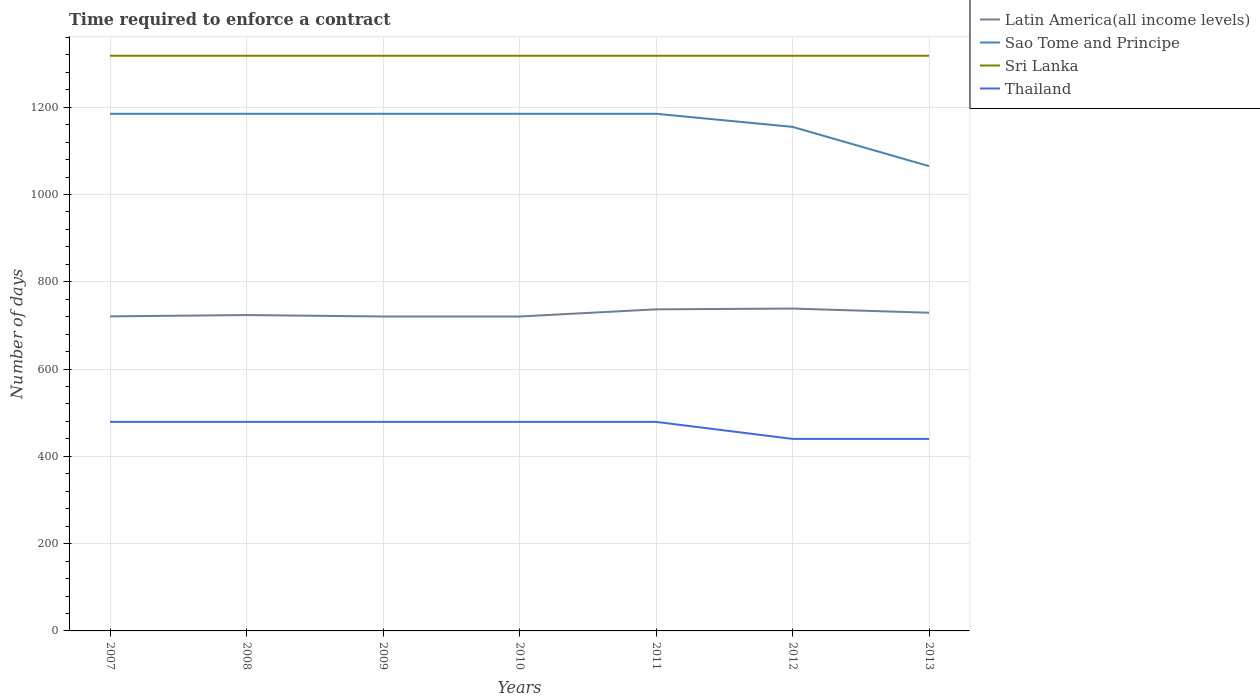How many different coloured lines are there?
Your answer should be compact. 4. Across all years, what is the maximum number of days required to enforce a contract in Sao Tome and Principe?
Offer a very short reply. 1065. In which year was the number of days required to enforce a contract in Latin America(all income levels) maximum?
Keep it short and to the point. 2009. What is the total number of days required to enforce a contract in Sri Lanka in the graph?
Provide a short and direct response. 0. What is the difference between the highest and the second highest number of days required to enforce a contract in Sao Tome and Principe?
Your response must be concise. 120. What is the difference between two consecutive major ticks on the Y-axis?
Keep it short and to the point. 200. Are the values on the major ticks of Y-axis written in scientific E-notation?
Provide a short and direct response. No. Does the graph contain grids?
Make the answer very short. Yes. How are the legend labels stacked?
Your response must be concise. Vertical. What is the title of the graph?
Offer a terse response. Time required to enforce a contract. Does "Thailand" appear as one of the legend labels in the graph?
Your answer should be compact. Yes. What is the label or title of the X-axis?
Your answer should be compact. Years. What is the label or title of the Y-axis?
Keep it short and to the point. Number of days. What is the Number of days in Latin America(all income levels) in 2007?
Keep it short and to the point. 720.8. What is the Number of days in Sao Tome and Principe in 2007?
Keep it short and to the point. 1185. What is the Number of days in Sri Lanka in 2007?
Make the answer very short. 1318. What is the Number of days of Thailand in 2007?
Your response must be concise. 479. What is the Number of days in Latin America(all income levels) in 2008?
Provide a short and direct response. 723.8. What is the Number of days in Sao Tome and Principe in 2008?
Make the answer very short. 1185. What is the Number of days in Sri Lanka in 2008?
Provide a short and direct response. 1318. What is the Number of days of Thailand in 2008?
Provide a short and direct response. 479. What is the Number of days of Latin America(all income levels) in 2009?
Your answer should be very brief. 720.47. What is the Number of days in Sao Tome and Principe in 2009?
Give a very brief answer. 1185. What is the Number of days in Sri Lanka in 2009?
Your answer should be very brief. 1318. What is the Number of days of Thailand in 2009?
Offer a terse response. 479. What is the Number of days of Latin America(all income levels) in 2010?
Provide a succinct answer. 720.47. What is the Number of days in Sao Tome and Principe in 2010?
Make the answer very short. 1185. What is the Number of days in Sri Lanka in 2010?
Make the answer very short. 1318. What is the Number of days in Thailand in 2010?
Your answer should be very brief. 479. What is the Number of days in Latin America(all income levels) in 2011?
Your answer should be very brief. 736.87. What is the Number of days of Sao Tome and Principe in 2011?
Your answer should be compact. 1185. What is the Number of days of Sri Lanka in 2011?
Your answer should be compact. 1318. What is the Number of days of Thailand in 2011?
Your answer should be compact. 479. What is the Number of days of Latin America(all income levels) in 2012?
Offer a terse response. 738.65. What is the Number of days in Sao Tome and Principe in 2012?
Your answer should be very brief. 1155. What is the Number of days of Sri Lanka in 2012?
Keep it short and to the point. 1318. What is the Number of days in Thailand in 2012?
Your answer should be compact. 440. What is the Number of days of Latin America(all income levels) in 2013?
Your response must be concise. 729.12. What is the Number of days of Sao Tome and Principe in 2013?
Offer a terse response. 1065. What is the Number of days of Sri Lanka in 2013?
Keep it short and to the point. 1318. What is the Number of days of Thailand in 2013?
Offer a very short reply. 440. Across all years, what is the maximum Number of days of Latin America(all income levels)?
Provide a succinct answer. 738.65. Across all years, what is the maximum Number of days of Sao Tome and Principe?
Your answer should be compact. 1185. Across all years, what is the maximum Number of days of Sri Lanka?
Offer a very short reply. 1318. Across all years, what is the maximum Number of days of Thailand?
Make the answer very short. 479. Across all years, what is the minimum Number of days in Latin America(all income levels)?
Offer a very short reply. 720.47. Across all years, what is the minimum Number of days in Sao Tome and Principe?
Give a very brief answer. 1065. Across all years, what is the minimum Number of days of Sri Lanka?
Keep it short and to the point. 1318. Across all years, what is the minimum Number of days of Thailand?
Offer a very short reply. 440. What is the total Number of days in Latin America(all income levels) in the graph?
Your answer should be compact. 5090.17. What is the total Number of days in Sao Tome and Principe in the graph?
Give a very brief answer. 8145. What is the total Number of days of Sri Lanka in the graph?
Ensure brevity in your answer.  9226. What is the total Number of days in Thailand in the graph?
Make the answer very short. 3275. What is the difference between the Number of days in Latin America(all income levels) in 2007 and that in 2008?
Offer a terse response. -3. What is the difference between the Number of days of Sao Tome and Principe in 2007 and that in 2008?
Make the answer very short. 0. What is the difference between the Number of days in Latin America(all income levels) in 2007 and that in 2009?
Offer a terse response. 0.33. What is the difference between the Number of days of Sri Lanka in 2007 and that in 2009?
Your answer should be very brief. 0. What is the difference between the Number of days in Latin America(all income levels) in 2007 and that in 2010?
Ensure brevity in your answer.  0.33. What is the difference between the Number of days of Sri Lanka in 2007 and that in 2010?
Offer a terse response. 0. What is the difference between the Number of days of Latin America(all income levels) in 2007 and that in 2011?
Provide a short and direct response. -16.07. What is the difference between the Number of days of Sri Lanka in 2007 and that in 2011?
Keep it short and to the point. 0. What is the difference between the Number of days in Thailand in 2007 and that in 2011?
Offer a terse response. 0. What is the difference between the Number of days in Latin America(all income levels) in 2007 and that in 2012?
Make the answer very short. -17.85. What is the difference between the Number of days of Sri Lanka in 2007 and that in 2012?
Give a very brief answer. 0. What is the difference between the Number of days in Thailand in 2007 and that in 2012?
Your response must be concise. 39. What is the difference between the Number of days of Latin America(all income levels) in 2007 and that in 2013?
Keep it short and to the point. -8.32. What is the difference between the Number of days in Sao Tome and Principe in 2007 and that in 2013?
Your answer should be very brief. 120. What is the difference between the Number of days of Latin America(all income levels) in 2008 and that in 2009?
Provide a short and direct response. 3.33. What is the difference between the Number of days of Sao Tome and Principe in 2008 and that in 2009?
Ensure brevity in your answer.  0. What is the difference between the Number of days of Sri Lanka in 2008 and that in 2009?
Keep it short and to the point. 0. What is the difference between the Number of days in Thailand in 2008 and that in 2009?
Offer a terse response. 0. What is the difference between the Number of days in Latin America(all income levels) in 2008 and that in 2010?
Make the answer very short. 3.33. What is the difference between the Number of days in Sao Tome and Principe in 2008 and that in 2010?
Ensure brevity in your answer.  0. What is the difference between the Number of days of Sri Lanka in 2008 and that in 2010?
Provide a succinct answer. 0. What is the difference between the Number of days of Thailand in 2008 and that in 2010?
Your answer should be compact. 0. What is the difference between the Number of days of Latin America(all income levels) in 2008 and that in 2011?
Provide a short and direct response. -13.07. What is the difference between the Number of days in Sri Lanka in 2008 and that in 2011?
Offer a terse response. 0. What is the difference between the Number of days of Thailand in 2008 and that in 2011?
Give a very brief answer. 0. What is the difference between the Number of days in Latin America(all income levels) in 2008 and that in 2012?
Make the answer very short. -14.85. What is the difference between the Number of days of Sao Tome and Principe in 2008 and that in 2012?
Your answer should be compact. 30. What is the difference between the Number of days of Sri Lanka in 2008 and that in 2012?
Offer a very short reply. 0. What is the difference between the Number of days in Latin America(all income levels) in 2008 and that in 2013?
Ensure brevity in your answer.  -5.32. What is the difference between the Number of days in Sao Tome and Principe in 2008 and that in 2013?
Your response must be concise. 120. What is the difference between the Number of days in Sri Lanka in 2008 and that in 2013?
Ensure brevity in your answer.  0. What is the difference between the Number of days of Latin America(all income levels) in 2009 and that in 2010?
Give a very brief answer. 0. What is the difference between the Number of days in Sri Lanka in 2009 and that in 2010?
Provide a short and direct response. 0. What is the difference between the Number of days of Thailand in 2009 and that in 2010?
Give a very brief answer. 0. What is the difference between the Number of days of Latin America(all income levels) in 2009 and that in 2011?
Offer a very short reply. -16.4. What is the difference between the Number of days in Latin America(all income levels) in 2009 and that in 2012?
Make the answer very short. -18.18. What is the difference between the Number of days of Thailand in 2009 and that in 2012?
Ensure brevity in your answer.  39. What is the difference between the Number of days in Latin America(all income levels) in 2009 and that in 2013?
Your response must be concise. -8.65. What is the difference between the Number of days in Sao Tome and Principe in 2009 and that in 2013?
Make the answer very short. 120. What is the difference between the Number of days in Latin America(all income levels) in 2010 and that in 2011?
Give a very brief answer. -16.4. What is the difference between the Number of days of Sao Tome and Principe in 2010 and that in 2011?
Provide a short and direct response. 0. What is the difference between the Number of days in Sri Lanka in 2010 and that in 2011?
Offer a very short reply. 0. What is the difference between the Number of days in Latin America(all income levels) in 2010 and that in 2012?
Give a very brief answer. -18.18. What is the difference between the Number of days of Sao Tome and Principe in 2010 and that in 2012?
Your response must be concise. 30. What is the difference between the Number of days of Thailand in 2010 and that in 2012?
Your response must be concise. 39. What is the difference between the Number of days in Latin America(all income levels) in 2010 and that in 2013?
Provide a short and direct response. -8.65. What is the difference between the Number of days of Sao Tome and Principe in 2010 and that in 2013?
Your response must be concise. 120. What is the difference between the Number of days of Latin America(all income levels) in 2011 and that in 2012?
Offer a very short reply. -1.77. What is the difference between the Number of days of Sri Lanka in 2011 and that in 2012?
Your answer should be compact. 0. What is the difference between the Number of days in Thailand in 2011 and that in 2012?
Offer a very short reply. 39. What is the difference between the Number of days in Latin America(all income levels) in 2011 and that in 2013?
Give a very brief answer. 7.75. What is the difference between the Number of days in Sao Tome and Principe in 2011 and that in 2013?
Keep it short and to the point. 120. What is the difference between the Number of days in Sri Lanka in 2011 and that in 2013?
Offer a terse response. 0. What is the difference between the Number of days of Latin America(all income levels) in 2012 and that in 2013?
Your answer should be very brief. 9.52. What is the difference between the Number of days of Thailand in 2012 and that in 2013?
Keep it short and to the point. 0. What is the difference between the Number of days of Latin America(all income levels) in 2007 and the Number of days of Sao Tome and Principe in 2008?
Make the answer very short. -464.2. What is the difference between the Number of days of Latin America(all income levels) in 2007 and the Number of days of Sri Lanka in 2008?
Keep it short and to the point. -597.2. What is the difference between the Number of days of Latin America(all income levels) in 2007 and the Number of days of Thailand in 2008?
Your answer should be compact. 241.8. What is the difference between the Number of days in Sao Tome and Principe in 2007 and the Number of days in Sri Lanka in 2008?
Your answer should be very brief. -133. What is the difference between the Number of days in Sao Tome and Principe in 2007 and the Number of days in Thailand in 2008?
Your response must be concise. 706. What is the difference between the Number of days in Sri Lanka in 2007 and the Number of days in Thailand in 2008?
Offer a very short reply. 839. What is the difference between the Number of days in Latin America(all income levels) in 2007 and the Number of days in Sao Tome and Principe in 2009?
Your response must be concise. -464.2. What is the difference between the Number of days of Latin America(all income levels) in 2007 and the Number of days of Sri Lanka in 2009?
Your answer should be compact. -597.2. What is the difference between the Number of days in Latin America(all income levels) in 2007 and the Number of days in Thailand in 2009?
Your response must be concise. 241.8. What is the difference between the Number of days of Sao Tome and Principe in 2007 and the Number of days of Sri Lanka in 2009?
Your answer should be compact. -133. What is the difference between the Number of days of Sao Tome and Principe in 2007 and the Number of days of Thailand in 2009?
Offer a very short reply. 706. What is the difference between the Number of days in Sri Lanka in 2007 and the Number of days in Thailand in 2009?
Provide a short and direct response. 839. What is the difference between the Number of days in Latin America(all income levels) in 2007 and the Number of days in Sao Tome and Principe in 2010?
Your answer should be very brief. -464.2. What is the difference between the Number of days in Latin America(all income levels) in 2007 and the Number of days in Sri Lanka in 2010?
Your answer should be very brief. -597.2. What is the difference between the Number of days in Latin America(all income levels) in 2007 and the Number of days in Thailand in 2010?
Offer a very short reply. 241.8. What is the difference between the Number of days of Sao Tome and Principe in 2007 and the Number of days of Sri Lanka in 2010?
Offer a terse response. -133. What is the difference between the Number of days of Sao Tome and Principe in 2007 and the Number of days of Thailand in 2010?
Provide a succinct answer. 706. What is the difference between the Number of days of Sri Lanka in 2007 and the Number of days of Thailand in 2010?
Offer a very short reply. 839. What is the difference between the Number of days in Latin America(all income levels) in 2007 and the Number of days in Sao Tome and Principe in 2011?
Make the answer very short. -464.2. What is the difference between the Number of days in Latin America(all income levels) in 2007 and the Number of days in Sri Lanka in 2011?
Ensure brevity in your answer.  -597.2. What is the difference between the Number of days of Latin America(all income levels) in 2007 and the Number of days of Thailand in 2011?
Your answer should be compact. 241.8. What is the difference between the Number of days of Sao Tome and Principe in 2007 and the Number of days of Sri Lanka in 2011?
Your answer should be very brief. -133. What is the difference between the Number of days of Sao Tome and Principe in 2007 and the Number of days of Thailand in 2011?
Offer a very short reply. 706. What is the difference between the Number of days of Sri Lanka in 2007 and the Number of days of Thailand in 2011?
Give a very brief answer. 839. What is the difference between the Number of days of Latin America(all income levels) in 2007 and the Number of days of Sao Tome and Principe in 2012?
Offer a terse response. -434.2. What is the difference between the Number of days of Latin America(all income levels) in 2007 and the Number of days of Sri Lanka in 2012?
Offer a very short reply. -597.2. What is the difference between the Number of days in Latin America(all income levels) in 2007 and the Number of days in Thailand in 2012?
Make the answer very short. 280.8. What is the difference between the Number of days in Sao Tome and Principe in 2007 and the Number of days in Sri Lanka in 2012?
Your response must be concise. -133. What is the difference between the Number of days in Sao Tome and Principe in 2007 and the Number of days in Thailand in 2012?
Make the answer very short. 745. What is the difference between the Number of days of Sri Lanka in 2007 and the Number of days of Thailand in 2012?
Provide a succinct answer. 878. What is the difference between the Number of days in Latin America(all income levels) in 2007 and the Number of days in Sao Tome and Principe in 2013?
Make the answer very short. -344.2. What is the difference between the Number of days of Latin America(all income levels) in 2007 and the Number of days of Sri Lanka in 2013?
Keep it short and to the point. -597.2. What is the difference between the Number of days of Latin America(all income levels) in 2007 and the Number of days of Thailand in 2013?
Keep it short and to the point. 280.8. What is the difference between the Number of days of Sao Tome and Principe in 2007 and the Number of days of Sri Lanka in 2013?
Make the answer very short. -133. What is the difference between the Number of days in Sao Tome and Principe in 2007 and the Number of days in Thailand in 2013?
Your answer should be compact. 745. What is the difference between the Number of days in Sri Lanka in 2007 and the Number of days in Thailand in 2013?
Give a very brief answer. 878. What is the difference between the Number of days in Latin America(all income levels) in 2008 and the Number of days in Sao Tome and Principe in 2009?
Provide a succinct answer. -461.2. What is the difference between the Number of days of Latin America(all income levels) in 2008 and the Number of days of Sri Lanka in 2009?
Your response must be concise. -594.2. What is the difference between the Number of days of Latin America(all income levels) in 2008 and the Number of days of Thailand in 2009?
Offer a very short reply. 244.8. What is the difference between the Number of days in Sao Tome and Principe in 2008 and the Number of days in Sri Lanka in 2009?
Provide a short and direct response. -133. What is the difference between the Number of days in Sao Tome and Principe in 2008 and the Number of days in Thailand in 2009?
Provide a short and direct response. 706. What is the difference between the Number of days in Sri Lanka in 2008 and the Number of days in Thailand in 2009?
Provide a short and direct response. 839. What is the difference between the Number of days in Latin America(all income levels) in 2008 and the Number of days in Sao Tome and Principe in 2010?
Offer a terse response. -461.2. What is the difference between the Number of days of Latin America(all income levels) in 2008 and the Number of days of Sri Lanka in 2010?
Your answer should be very brief. -594.2. What is the difference between the Number of days in Latin America(all income levels) in 2008 and the Number of days in Thailand in 2010?
Your response must be concise. 244.8. What is the difference between the Number of days of Sao Tome and Principe in 2008 and the Number of days of Sri Lanka in 2010?
Offer a terse response. -133. What is the difference between the Number of days in Sao Tome and Principe in 2008 and the Number of days in Thailand in 2010?
Give a very brief answer. 706. What is the difference between the Number of days in Sri Lanka in 2008 and the Number of days in Thailand in 2010?
Your answer should be compact. 839. What is the difference between the Number of days in Latin America(all income levels) in 2008 and the Number of days in Sao Tome and Principe in 2011?
Your response must be concise. -461.2. What is the difference between the Number of days of Latin America(all income levels) in 2008 and the Number of days of Sri Lanka in 2011?
Give a very brief answer. -594.2. What is the difference between the Number of days in Latin America(all income levels) in 2008 and the Number of days in Thailand in 2011?
Keep it short and to the point. 244.8. What is the difference between the Number of days of Sao Tome and Principe in 2008 and the Number of days of Sri Lanka in 2011?
Give a very brief answer. -133. What is the difference between the Number of days in Sao Tome and Principe in 2008 and the Number of days in Thailand in 2011?
Keep it short and to the point. 706. What is the difference between the Number of days of Sri Lanka in 2008 and the Number of days of Thailand in 2011?
Your response must be concise. 839. What is the difference between the Number of days of Latin America(all income levels) in 2008 and the Number of days of Sao Tome and Principe in 2012?
Give a very brief answer. -431.2. What is the difference between the Number of days in Latin America(all income levels) in 2008 and the Number of days in Sri Lanka in 2012?
Your response must be concise. -594.2. What is the difference between the Number of days of Latin America(all income levels) in 2008 and the Number of days of Thailand in 2012?
Provide a short and direct response. 283.8. What is the difference between the Number of days of Sao Tome and Principe in 2008 and the Number of days of Sri Lanka in 2012?
Offer a very short reply. -133. What is the difference between the Number of days of Sao Tome and Principe in 2008 and the Number of days of Thailand in 2012?
Provide a succinct answer. 745. What is the difference between the Number of days in Sri Lanka in 2008 and the Number of days in Thailand in 2012?
Make the answer very short. 878. What is the difference between the Number of days in Latin America(all income levels) in 2008 and the Number of days in Sao Tome and Principe in 2013?
Your answer should be very brief. -341.2. What is the difference between the Number of days in Latin America(all income levels) in 2008 and the Number of days in Sri Lanka in 2013?
Ensure brevity in your answer.  -594.2. What is the difference between the Number of days in Latin America(all income levels) in 2008 and the Number of days in Thailand in 2013?
Offer a terse response. 283.8. What is the difference between the Number of days in Sao Tome and Principe in 2008 and the Number of days in Sri Lanka in 2013?
Give a very brief answer. -133. What is the difference between the Number of days of Sao Tome and Principe in 2008 and the Number of days of Thailand in 2013?
Give a very brief answer. 745. What is the difference between the Number of days of Sri Lanka in 2008 and the Number of days of Thailand in 2013?
Your response must be concise. 878. What is the difference between the Number of days in Latin America(all income levels) in 2009 and the Number of days in Sao Tome and Principe in 2010?
Your answer should be compact. -464.53. What is the difference between the Number of days in Latin America(all income levels) in 2009 and the Number of days in Sri Lanka in 2010?
Provide a short and direct response. -597.53. What is the difference between the Number of days in Latin America(all income levels) in 2009 and the Number of days in Thailand in 2010?
Give a very brief answer. 241.47. What is the difference between the Number of days in Sao Tome and Principe in 2009 and the Number of days in Sri Lanka in 2010?
Make the answer very short. -133. What is the difference between the Number of days of Sao Tome and Principe in 2009 and the Number of days of Thailand in 2010?
Make the answer very short. 706. What is the difference between the Number of days of Sri Lanka in 2009 and the Number of days of Thailand in 2010?
Your answer should be compact. 839. What is the difference between the Number of days of Latin America(all income levels) in 2009 and the Number of days of Sao Tome and Principe in 2011?
Keep it short and to the point. -464.53. What is the difference between the Number of days in Latin America(all income levels) in 2009 and the Number of days in Sri Lanka in 2011?
Provide a short and direct response. -597.53. What is the difference between the Number of days of Latin America(all income levels) in 2009 and the Number of days of Thailand in 2011?
Ensure brevity in your answer.  241.47. What is the difference between the Number of days of Sao Tome and Principe in 2009 and the Number of days of Sri Lanka in 2011?
Offer a very short reply. -133. What is the difference between the Number of days in Sao Tome and Principe in 2009 and the Number of days in Thailand in 2011?
Keep it short and to the point. 706. What is the difference between the Number of days in Sri Lanka in 2009 and the Number of days in Thailand in 2011?
Give a very brief answer. 839. What is the difference between the Number of days in Latin America(all income levels) in 2009 and the Number of days in Sao Tome and Principe in 2012?
Your response must be concise. -434.53. What is the difference between the Number of days in Latin America(all income levels) in 2009 and the Number of days in Sri Lanka in 2012?
Offer a very short reply. -597.53. What is the difference between the Number of days in Latin America(all income levels) in 2009 and the Number of days in Thailand in 2012?
Make the answer very short. 280.47. What is the difference between the Number of days in Sao Tome and Principe in 2009 and the Number of days in Sri Lanka in 2012?
Your answer should be compact. -133. What is the difference between the Number of days in Sao Tome and Principe in 2009 and the Number of days in Thailand in 2012?
Give a very brief answer. 745. What is the difference between the Number of days of Sri Lanka in 2009 and the Number of days of Thailand in 2012?
Your answer should be very brief. 878. What is the difference between the Number of days in Latin America(all income levels) in 2009 and the Number of days in Sao Tome and Principe in 2013?
Keep it short and to the point. -344.53. What is the difference between the Number of days of Latin America(all income levels) in 2009 and the Number of days of Sri Lanka in 2013?
Provide a short and direct response. -597.53. What is the difference between the Number of days of Latin America(all income levels) in 2009 and the Number of days of Thailand in 2013?
Your response must be concise. 280.47. What is the difference between the Number of days in Sao Tome and Principe in 2009 and the Number of days in Sri Lanka in 2013?
Make the answer very short. -133. What is the difference between the Number of days in Sao Tome and Principe in 2009 and the Number of days in Thailand in 2013?
Offer a very short reply. 745. What is the difference between the Number of days in Sri Lanka in 2009 and the Number of days in Thailand in 2013?
Ensure brevity in your answer.  878. What is the difference between the Number of days of Latin America(all income levels) in 2010 and the Number of days of Sao Tome and Principe in 2011?
Your answer should be very brief. -464.53. What is the difference between the Number of days of Latin America(all income levels) in 2010 and the Number of days of Sri Lanka in 2011?
Offer a very short reply. -597.53. What is the difference between the Number of days of Latin America(all income levels) in 2010 and the Number of days of Thailand in 2011?
Provide a succinct answer. 241.47. What is the difference between the Number of days of Sao Tome and Principe in 2010 and the Number of days of Sri Lanka in 2011?
Provide a succinct answer. -133. What is the difference between the Number of days of Sao Tome and Principe in 2010 and the Number of days of Thailand in 2011?
Give a very brief answer. 706. What is the difference between the Number of days of Sri Lanka in 2010 and the Number of days of Thailand in 2011?
Your answer should be very brief. 839. What is the difference between the Number of days of Latin America(all income levels) in 2010 and the Number of days of Sao Tome and Principe in 2012?
Your response must be concise. -434.53. What is the difference between the Number of days in Latin America(all income levels) in 2010 and the Number of days in Sri Lanka in 2012?
Offer a terse response. -597.53. What is the difference between the Number of days in Latin America(all income levels) in 2010 and the Number of days in Thailand in 2012?
Provide a succinct answer. 280.47. What is the difference between the Number of days of Sao Tome and Principe in 2010 and the Number of days of Sri Lanka in 2012?
Provide a short and direct response. -133. What is the difference between the Number of days of Sao Tome and Principe in 2010 and the Number of days of Thailand in 2012?
Your answer should be very brief. 745. What is the difference between the Number of days of Sri Lanka in 2010 and the Number of days of Thailand in 2012?
Offer a terse response. 878. What is the difference between the Number of days of Latin America(all income levels) in 2010 and the Number of days of Sao Tome and Principe in 2013?
Ensure brevity in your answer.  -344.53. What is the difference between the Number of days in Latin America(all income levels) in 2010 and the Number of days in Sri Lanka in 2013?
Keep it short and to the point. -597.53. What is the difference between the Number of days of Latin America(all income levels) in 2010 and the Number of days of Thailand in 2013?
Offer a very short reply. 280.47. What is the difference between the Number of days of Sao Tome and Principe in 2010 and the Number of days of Sri Lanka in 2013?
Your answer should be compact. -133. What is the difference between the Number of days in Sao Tome and Principe in 2010 and the Number of days in Thailand in 2013?
Make the answer very short. 745. What is the difference between the Number of days in Sri Lanka in 2010 and the Number of days in Thailand in 2013?
Your answer should be compact. 878. What is the difference between the Number of days of Latin America(all income levels) in 2011 and the Number of days of Sao Tome and Principe in 2012?
Provide a succinct answer. -418.13. What is the difference between the Number of days of Latin America(all income levels) in 2011 and the Number of days of Sri Lanka in 2012?
Make the answer very short. -581.13. What is the difference between the Number of days in Latin America(all income levels) in 2011 and the Number of days in Thailand in 2012?
Your answer should be very brief. 296.87. What is the difference between the Number of days in Sao Tome and Principe in 2011 and the Number of days in Sri Lanka in 2012?
Keep it short and to the point. -133. What is the difference between the Number of days in Sao Tome and Principe in 2011 and the Number of days in Thailand in 2012?
Keep it short and to the point. 745. What is the difference between the Number of days of Sri Lanka in 2011 and the Number of days of Thailand in 2012?
Ensure brevity in your answer.  878. What is the difference between the Number of days in Latin America(all income levels) in 2011 and the Number of days in Sao Tome and Principe in 2013?
Keep it short and to the point. -328.13. What is the difference between the Number of days of Latin America(all income levels) in 2011 and the Number of days of Sri Lanka in 2013?
Your response must be concise. -581.13. What is the difference between the Number of days in Latin America(all income levels) in 2011 and the Number of days in Thailand in 2013?
Provide a succinct answer. 296.87. What is the difference between the Number of days in Sao Tome and Principe in 2011 and the Number of days in Sri Lanka in 2013?
Your response must be concise. -133. What is the difference between the Number of days of Sao Tome and Principe in 2011 and the Number of days of Thailand in 2013?
Your answer should be very brief. 745. What is the difference between the Number of days in Sri Lanka in 2011 and the Number of days in Thailand in 2013?
Give a very brief answer. 878. What is the difference between the Number of days of Latin America(all income levels) in 2012 and the Number of days of Sao Tome and Principe in 2013?
Give a very brief answer. -326.35. What is the difference between the Number of days in Latin America(all income levels) in 2012 and the Number of days in Sri Lanka in 2013?
Your answer should be compact. -579.35. What is the difference between the Number of days of Latin America(all income levels) in 2012 and the Number of days of Thailand in 2013?
Ensure brevity in your answer.  298.65. What is the difference between the Number of days in Sao Tome and Principe in 2012 and the Number of days in Sri Lanka in 2013?
Offer a terse response. -163. What is the difference between the Number of days in Sao Tome and Principe in 2012 and the Number of days in Thailand in 2013?
Ensure brevity in your answer.  715. What is the difference between the Number of days of Sri Lanka in 2012 and the Number of days of Thailand in 2013?
Make the answer very short. 878. What is the average Number of days of Latin America(all income levels) per year?
Offer a very short reply. 727.17. What is the average Number of days of Sao Tome and Principe per year?
Your answer should be very brief. 1163.57. What is the average Number of days of Sri Lanka per year?
Ensure brevity in your answer.  1318. What is the average Number of days in Thailand per year?
Give a very brief answer. 467.86. In the year 2007, what is the difference between the Number of days of Latin America(all income levels) and Number of days of Sao Tome and Principe?
Give a very brief answer. -464.2. In the year 2007, what is the difference between the Number of days in Latin America(all income levels) and Number of days in Sri Lanka?
Ensure brevity in your answer.  -597.2. In the year 2007, what is the difference between the Number of days of Latin America(all income levels) and Number of days of Thailand?
Your answer should be compact. 241.8. In the year 2007, what is the difference between the Number of days of Sao Tome and Principe and Number of days of Sri Lanka?
Your response must be concise. -133. In the year 2007, what is the difference between the Number of days in Sao Tome and Principe and Number of days in Thailand?
Provide a succinct answer. 706. In the year 2007, what is the difference between the Number of days in Sri Lanka and Number of days in Thailand?
Ensure brevity in your answer.  839. In the year 2008, what is the difference between the Number of days of Latin America(all income levels) and Number of days of Sao Tome and Principe?
Make the answer very short. -461.2. In the year 2008, what is the difference between the Number of days of Latin America(all income levels) and Number of days of Sri Lanka?
Ensure brevity in your answer.  -594.2. In the year 2008, what is the difference between the Number of days of Latin America(all income levels) and Number of days of Thailand?
Your response must be concise. 244.8. In the year 2008, what is the difference between the Number of days of Sao Tome and Principe and Number of days of Sri Lanka?
Your answer should be compact. -133. In the year 2008, what is the difference between the Number of days in Sao Tome and Principe and Number of days in Thailand?
Ensure brevity in your answer.  706. In the year 2008, what is the difference between the Number of days of Sri Lanka and Number of days of Thailand?
Provide a short and direct response. 839. In the year 2009, what is the difference between the Number of days of Latin America(all income levels) and Number of days of Sao Tome and Principe?
Provide a short and direct response. -464.53. In the year 2009, what is the difference between the Number of days in Latin America(all income levels) and Number of days in Sri Lanka?
Provide a succinct answer. -597.53. In the year 2009, what is the difference between the Number of days of Latin America(all income levels) and Number of days of Thailand?
Give a very brief answer. 241.47. In the year 2009, what is the difference between the Number of days of Sao Tome and Principe and Number of days of Sri Lanka?
Your response must be concise. -133. In the year 2009, what is the difference between the Number of days of Sao Tome and Principe and Number of days of Thailand?
Your answer should be compact. 706. In the year 2009, what is the difference between the Number of days of Sri Lanka and Number of days of Thailand?
Your response must be concise. 839. In the year 2010, what is the difference between the Number of days of Latin America(all income levels) and Number of days of Sao Tome and Principe?
Provide a succinct answer. -464.53. In the year 2010, what is the difference between the Number of days in Latin America(all income levels) and Number of days in Sri Lanka?
Offer a terse response. -597.53. In the year 2010, what is the difference between the Number of days of Latin America(all income levels) and Number of days of Thailand?
Offer a terse response. 241.47. In the year 2010, what is the difference between the Number of days of Sao Tome and Principe and Number of days of Sri Lanka?
Offer a terse response. -133. In the year 2010, what is the difference between the Number of days in Sao Tome and Principe and Number of days in Thailand?
Provide a short and direct response. 706. In the year 2010, what is the difference between the Number of days of Sri Lanka and Number of days of Thailand?
Your response must be concise. 839. In the year 2011, what is the difference between the Number of days of Latin America(all income levels) and Number of days of Sao Tome and Principe?
Ensure brevity in your answer.  -448.13. In the year 2011, what is the difference between the Number of days of Latin America(all income levels) and Number of days of Sri Lanka?
Give a very brief answer. -581.13. In the year 2011, what is the difference between the Number of days in Latin America(all income levels) and Number of days in Thailand?
Make the answer very short. 257.87. In the year 2011, what is the difference between the Number of days in Sao Tome and Principe and Number of days in Sri Lanka?
Offer a very short reply. -133. In the year 2011, what is the difference between the Number of days in Sao Tome and Principe and Number of days in Thailand?
Your response must be concise. 706. In the year 2011, what is the difference between the Number of days in Sri Lanka and Number of days in Thailand?
Give a very brief answer. 839. In the year 2012, what is the difference between the Number of days in Latin America(all income levels) and Number of days in Sao Tome and Principe?
Provide a succinct answer. -416.35. In the year 2012, what is the difference between the Number of days in Latin America(all income levels) and Number of days in Sri Lanka?
Provide a short and direct response. -579.35. In the year 2012, what is the difference between the Number of days of Latin America(all income levels) and Number of days of Thailand?
Offer a terse response. 298.65. In the year 2012, what is the difference between the Number of days in Sao Tome and Principe and Number of days in Sri Lanka?
Your response must be concise. -163. In the year 2012, what is the difference between the Number of days of Sao Tome and Principe and Number of days of Thailand?
Your answer should be compact. 715. In the year 2012, what is the difference between the Number of days in Sri Lanka and Number of days in Thailand?
Make the answer very short. 878. In the year 2013, what is the difference between the Number of days of Latin America(all income levels) and Number of days of Sao Tome and Principe?
Your answer should be compact. -335.88. In the year 2013, what is the difference between the Number of days in Latin America(all income levels) and Number of days in Sri Lanka?
Make the answer very short. -588.88. In the year 2013, what is the difference between the Number of days of Latin America(all income levels) and Number of days of Thailand?
Keep it short and to the point. 289.12. In the year 2013, what is the difference between the Number of days of Sao Tome and Principe and Number of days of Sri Lanka?
Your response must be concise. -253. In the year 2013, what is the difference between the Number of days of Sao Tome and Principe and Number of days of Thailand?
Your response must be concise. 625. In the year 2013, what is the difference between the Number of days in Sri Lanka and Number of days in Thailand?
Offer a very short reply. 878. What is the ratio of the Number of days in Latin America(all income levels) in 2007 to that in 2008?
Offer a very short reply. 1. What is the ratio of the Number of days in Sao Tome and Principe in 2007 to that in 2008?
Provide a short and direct response. 1. What is the ratio of the Number of days of Sri Lanka in 2007 to that in 2008?
Your answer should be compact. 1. What is the ratio of the Number of days of Sao Tome and Principe in 2007 to that in 2009?
Your response must be concise. 1. What is the ratio of the Number of days in Sri Lanka in 2007 to that in 2009?
Make the answer very short. 1. What is the ratio of the Number of days in Sao Tome and Principe in 2007 to that in 2010?
Your response must be concise. 1. What is the ratio of the Number of days of Sri Lanka in 2007 to that in 2010?
Your answer should be very brief. 1. What is the ratio of the Number of days of Latin America(all income levels) in 2007 to that in 2011?
Your response must be concise. 0.98. What is the ratio of the Number of days in Sri Lanka in 2007 to that in 2011?
Your response must be concise. 1. What is the ratio of the Number of days in Latin America(all income levels) in 2007 to that in 2012?
Keep it short and to the point. 0.98. What is the ratio of the Number of days in Sao Tome and Principe in 2007 to that in 2012?
Your answer should be very brief. 1.03. What is the ratio of the Number of days of Thailand in 2007 to that in 2012?
Give a very brief answer. 1.09. What is the ratio of the Number of days of Sao Tome and Principe in 2007 to that in 2013?
Give a very brief answer. 1.11. What is the ratio of the Number of days of Thailand in 2007 to that in 2013?
Give a very brief answer. 1.09. What is the ratio of the Number of days of Sao Tome and Principe in 2008 to that in 2009?
Your answer should be very brief. 1. What is the ratio of the Number of days of Sri Lanka in 2008 to that in 2009?
Make the answer very short. 1. What is the ratio of the Number of days in Sri Lanka in 2008 to that in 2010?
Offer a terse response. 1. What is the ratio of the Number of days in Thailand in 2008 to that in 2010?
Your answer should be compact. 1. What is the ratio of the Number of days of Latin America(all income levels) in 2008 to that in 2011?
Your answer should be compact. 0.98. What is the ratio of the Number of days in Thailand in 2008 to that in 2011?
Your response must be concise. 1. What is the ratio of the Number of days of Latin America(all income levels) in 2008 to that in 2012?
Give a very brief answer. 0.98. What is the ratio of the Number of days of Sri Lanka in 2008 to that in 2012?
Keep it short and to the point. 1. What is the ratio of the Number of days in Thailand in 2008 to that in 2012?
Give a very brief answer. 1.09. What is the ratio of the Number of days of Latin America(all income levels) in 2008 to that in 2013?
Your answer should be compact. 0.99. What is the ratio of the Number of days in Sao Tome and Principe in 2008 to that in 2013?
Your response must be concise. 1.11. What is the ratio of the Number of days of Thailand in 2008 to that in 2013?
Provide a succinct answer. 1.09. What is the ratio of the Number of days of Thailand in 2009 to that in 2010?
Make the answer very short. 1. What is the ratio of the Number of days of Latin America(all income levels) in 2009 to that in 2011?
Provide a short and direct response. 0.98. What is the ratio of the Number of days in Latin America(all income levels) in 2009 to that in 2012?
Offer a very short reply. 0.98. What is the ratio of the Number of days in Sao Tome and Principe in 2009 to that in 2012?
Your response must be concise. 1.03. What is the ratio of the Number of days of Thailand in 2009 to that in 2012?
Your response must be concise. 1.09. What is the ratio of the Number of days of Sao Tome and Principe in 2009 to that in 2013?
Ensure brevity in your answer.  1.11. What is the ratio of the Number of days in Sri Lanka in 2009 to that in 2013?
Provide a short and direct response. 1. What is the ratio of the Number of days in Thailand in 2009 to that in 2013?
Your answer should be very brief. 1.09. What is the ratio of the Number of days of Latin America(all income levels) in 2010 to that in 2011?
Keep it short and to the point. 0.98. What is the ratio of the Number of days of Sri Lanka in 2010 to that in 2011?
Offer a very short reply. 1. What is the ratio of the Number of days in Latin America(all income levels) in 2010 to that in 2012?
Your response must be concise. 0.98. What is the ratio of the Number of days in Sao Tome and Principe in 2010 to that in 2012?
Give a very brief answer. 1.03. What is the ratio of the Number of days of Thailand in 2010 to that in 2012?
Provide a succinct answer. 1.09. What is the ratio of the Number of days of Sao Tome and Principe in 2010 to that in 2013?
Offer a very short reply. 1.11. What is the ratio of the Number of days of Sri Lanka in 2010 to that in 2013?
Offer a terse response. 1. What is the ratio of the Number of days of Thailand in 2010 to that in 2013?
Offer a very short reply. 1.09. What is the ratio of the Number of days of Latin America(all income levels) in 2011 to that in 2012?
Offer a terse response. 1. What is the ratio of the Number of days in Sao Tome and Principe in 2011 to that in 2012?
Your response must be concise. 1.03. What is the ratio of the Number of days in Sri Lanka in 2011 to that in 2012?
Make the answer very short. 1. What is the ratio of the Number of days of Thailand in 2011 to that in 2012?
Make the answer very short. 1.09. What is the ratio of the Number of days of Latin America(all income levels) in 2011 to that in 2013?
Your answer should be compact. 1.01. What is the ratio of the Number of days of Sao Tome and Principe in 2011 to that in 2013?
Ensure brevity in your answer.  1.11. What is the ratio of the Number of days of Sri Lanka in 2011 to that in 2013?
Provide a short and direct response. 1. What is the ratio of the Number of days of Thailand in 2011 to that in 2013?
Offer a very short reply. 1.09. What is the ratio of the Number of days of Latin America(all income levels) in 2012 to that in 2013?
Provide a short and direct response. 1.01. What is the ratio of the Number of days of Sao Tome and Principe in 2012 to that in 2013?
Give a very brief answer. 1.08. What is the ratio of the Number of days in Sri Lanka in 2012 to that in 2013?
Make the answer very short. 1. What is the difference between the highest and the second highest Number of days of Latin America(all income levels)?
Offer a terse response. 1.77. What is the difference between the highest and the second highest Number of days of Thailand?
Your answer should be very brief. 0. What is the difference between the highest and the lowest Number of days in Latin America(all income levels)?
Your answer should be compact. 18.18. What is the difference between the highest and the lowest Number of days of Sao Tome and Principe?
Offer a terse response. 120. What is the difference between the highest and the lowest Number of days in Sri Lanka?
Your answer should be compact. 0. 